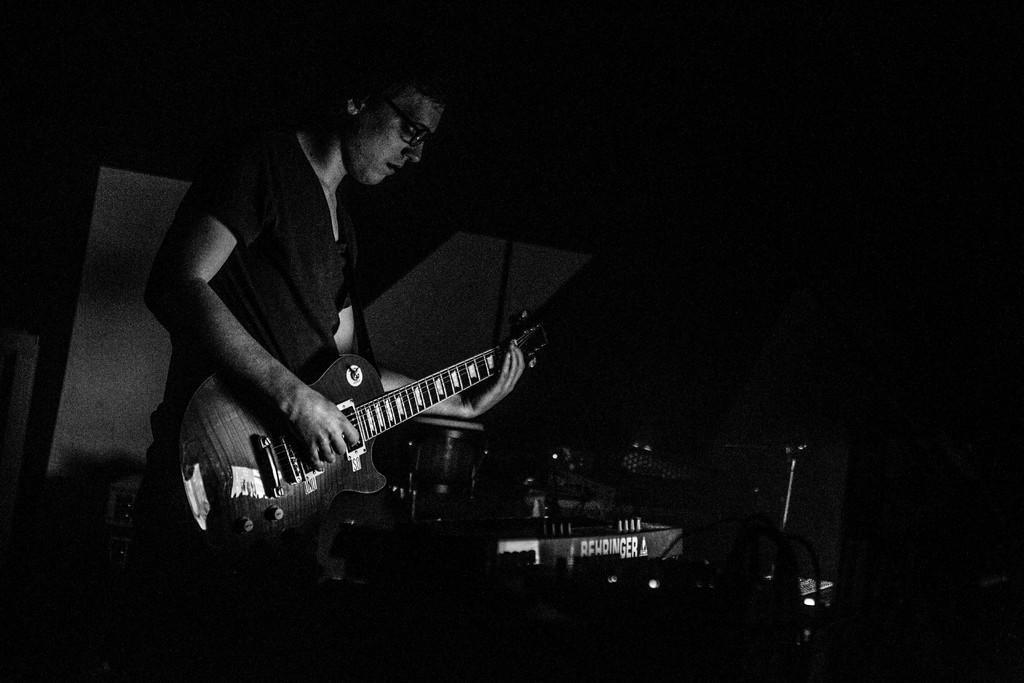In one or two sentences, can you explain what this image depicts? Here we can see a man who is playing guitar. He has spectacles. And these are some musical instruments. 